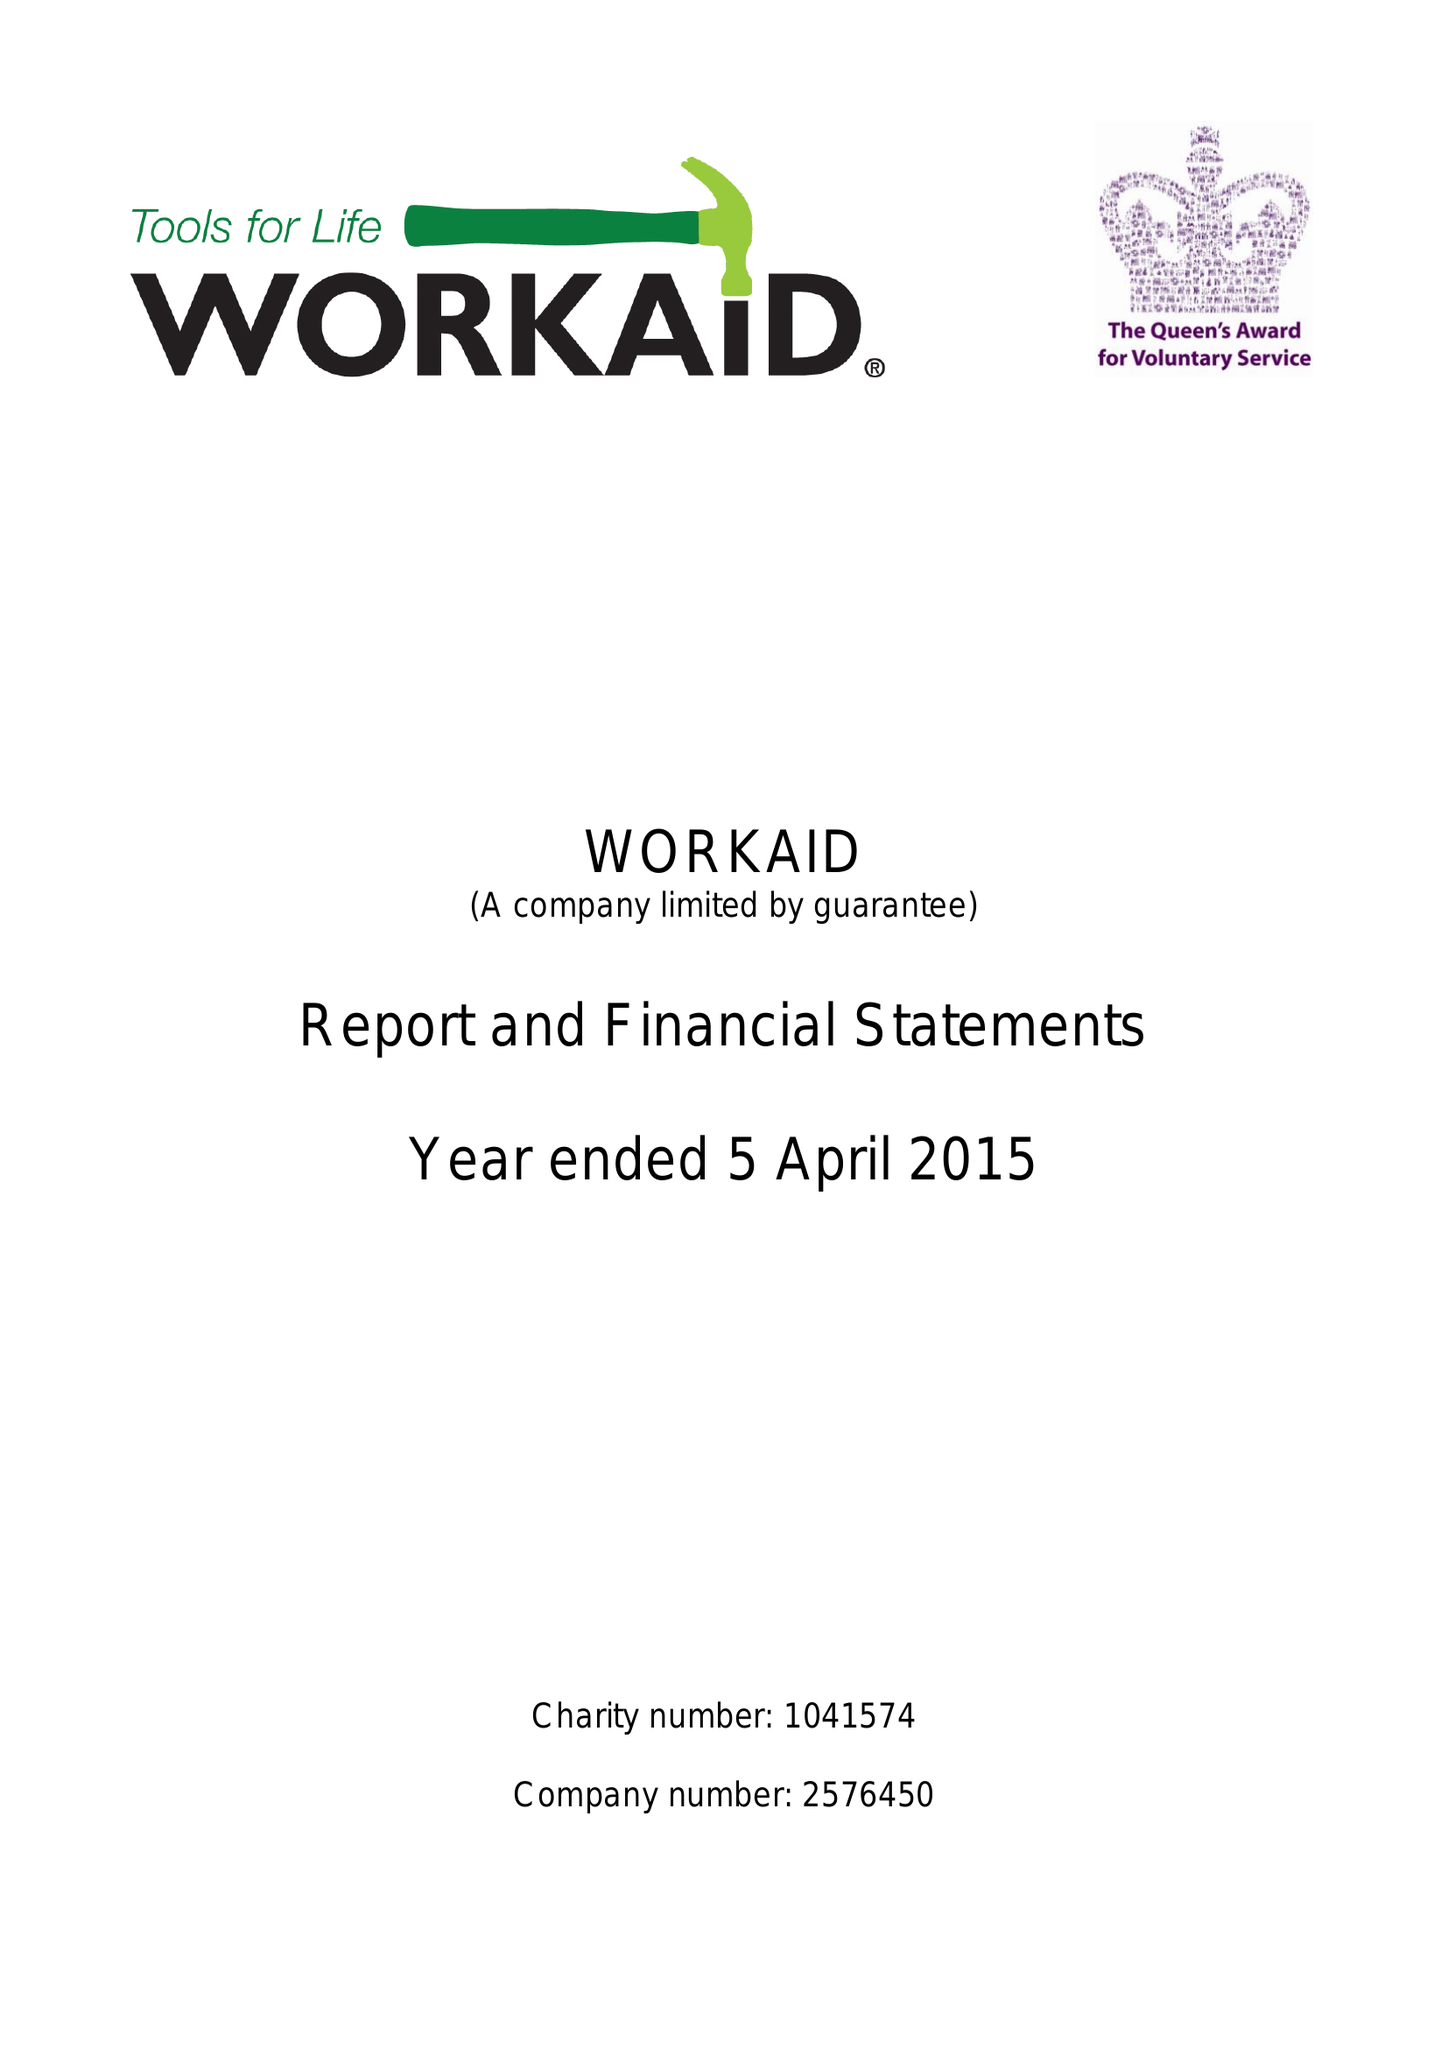What is the value for the address__post_town?
Answer the question using a single word or phrase. CHESHAM 